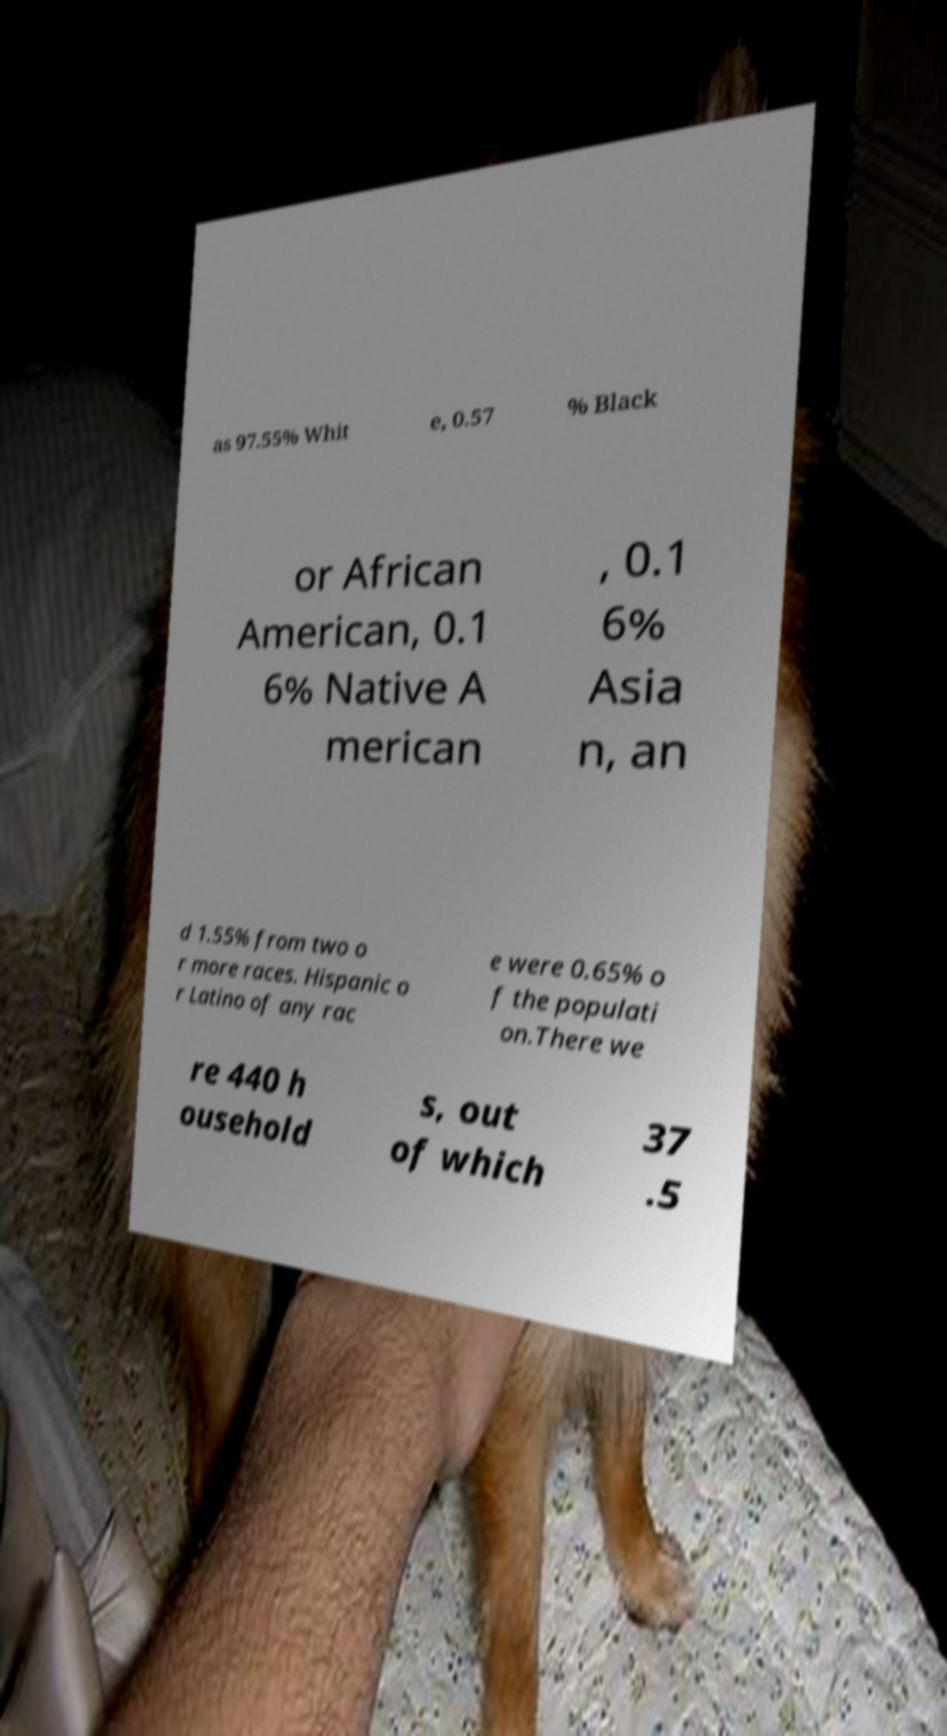I need the written content from this picture converted into text. Can you do that? as 97.55% Whit e, 0.57 % Black or African American, 0.1 6% Native A merican , 0.1 6% Asia n, an d 1.55% from two o r more races. Hispanic o r Latino of any rac e were 0.65% o f the populati on.There we re 440 h ousehold s, out of which 37 .5 